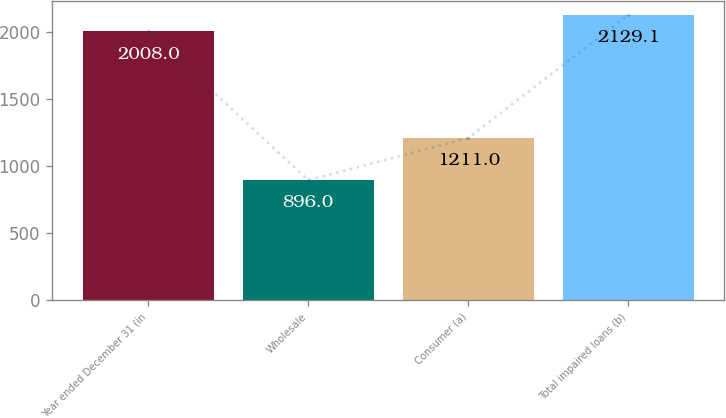Convert chart. <chart><loc_0><loc_0><loc_500><loc_500><bar_chart><fcel>Year ended December 31 (in<fcel>Wholesale<fcel>Consumer (a)<fcel>Total impaired loans (b)<nl><fcel>2008<fcel>896<fcel>1211<fcel>2129.1<nl></chart> 